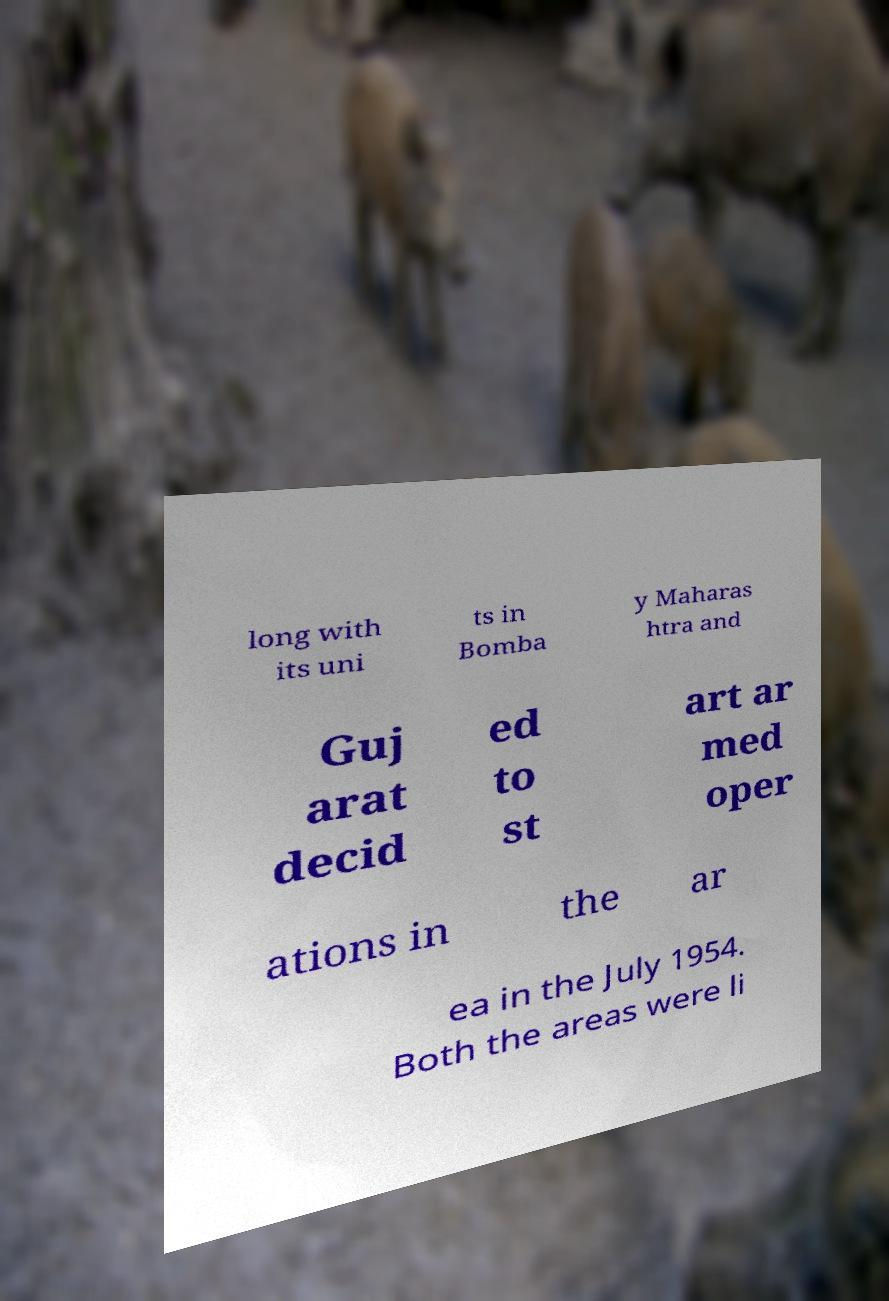For documentation purposes, I need the text within this image transcribed. Could you provide that? long with its uni ts in Bomba y Maharas htra and Guj arat decid ed to st art ar med oper ations in the ar ea in the July 1954. Both the areas were li 